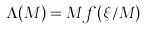<formula> <loc_0><loc_0><loc_500><loc_500>\Lambda ( M ) = M f ( \xi / M )</formula> 